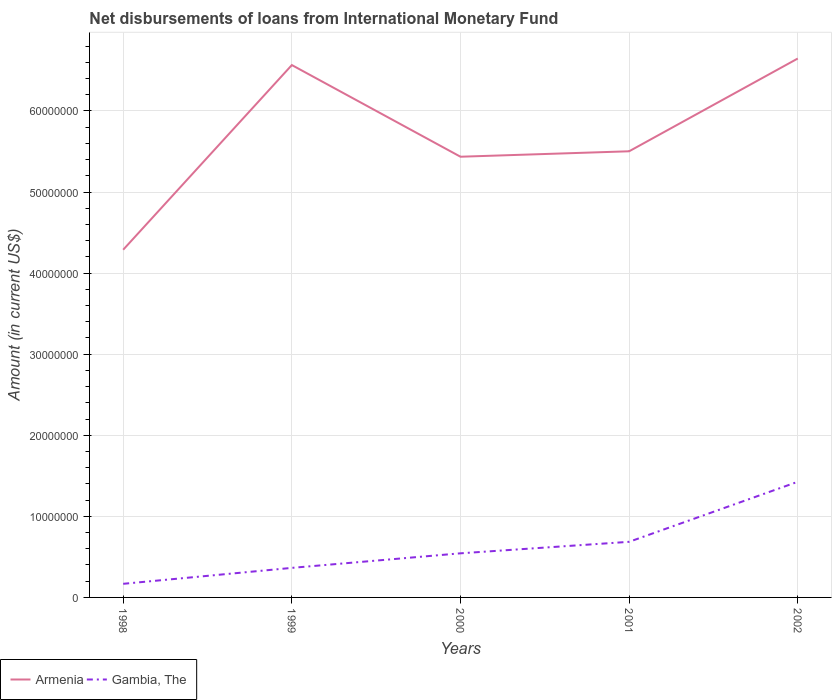Is the number of lines equal to the number of legend labels?
Make the answer very short. Yes. Across all years, what is the maximum amount of loans disbursed in Armenia?
Provide a short and direct response. 4.29e+07. In which year was the amount of loans disbursed in Gambia, The maximum?
Keep it short and to the point. 1998. What is the total amount of loans disbursed in Armenia in the graph?
Your answer should be compact. -1.14e+07. What is the difference between the highest and the second highest amount of loans disbursed in Gambia, The?
Ensure brevity in your answer.  1.26e+07. What is the difference between the highest and the lowest amount of loans disbursed in Gambia, The?
Provide a short and direct response. 2. How many lines are there?
Offer a terse response. 2. How many years are there in the graph?
Provide a short and direct response. 5. Does the graph contain grids?
Give a very brief answer. Yes. How are the legend labels stacked?
Make the answer very short. Horizontal. What is the title of the graph?
Offer a terse response. Net disbursements of loans from International Monetary Fund. What is the label or title of the X-axis?
Provide a succinct answer. Years. What is the Amount (in current US$) of Armenia in 1998?
Keep it short and to the point. 4.29e+07. What is the Amount (in current US$) of Gambia, The in 1998?
Your response must be concise. 1.68e+06. What is the Amount (in current US$) of Armenia in 1999?
Keep it short and to the point. 6.57e+07. What is the Amount (in current US$) in Gambia, The in 1999?
Give a very brief answer. 3.64e+06. What is the Amount (in current US$) in Armenia in 2000?
Offer a very short reply. 5.44e+07. What is the Amount (in current US$) of Gambia, The in 2000?
Make the answer very short. 5.44e+06. What is the Amount (in current US$) in Armenia in 2001?
Provide a succinct answer. 5.50e+07. What is the Amount (in current US$) in Gambia, The in 2001?
Ensure brevity in your answer.  6.86e+06. What is the Amount (in current US$) in Armenia in 2002?
Your answer should be compact. 6.65e+07. What is the Amount (in current US$) of Gambia, The in 2002?
Make the answer very short. 1.43e+07. Across all years, what is the maximum Amount (in current US$) in Armenia?
Provide a succinct answer. 6.65e+07. Across all years, what is the maximum Amount (in current US$) of Gambia, The?
Make the answer very short. 1.43e+07. Across all years, what is the minimum Amount (in current US$) of Armenia?
Your answer should be very brief. 4.29e+07. Across all years, what is the minimum Amount (in current US$) in Gambia, The?
Provide a short and direct response. 1.68e+06. What is the total Amount (in current US$) of Armenia in the graph?
Keep it short and to the point. 2.84e+08. What is the total Amount (in current US$) in Gambia, The in the graph?
Provide a succinct answer. 3.19e+07. What is the difference between the Amount (in current US$) of Armenia in 1998 and that in 1999?
Keep it short and to the point. -2.28e+07. What is the difference between the Amount (in current US$) in Gambia, The in 1998 and that in 1999?
Keep it short and to the point. -1.97e+06. What is the difference between the Amount (in current US$) in Armenia in 1998 and that in 2000?
Your answer should be compact. -1.15e+07. What is the difference between the Amount (in current US$) in Gambia, The in 1998 and that in 2000?
Ensure brevity in your answer.  -3.76e+06. What is the difference between the Amount (in current US$) of Armenia in 1998 and that in 2001?
Provide a succinct answer. -1.21e+07. What is the difference between the Amount (in current US$) in Gambia, The in 1998 and that in 2001?
Provide a succinct answer. -5.18e+06. What is the difference between the Amount (in current US$) of Armenia in 1998 and that in 2002?
Your answer should be very brief. -2.36e+07. What is the difference between the Amount (in current US$) in Gambia, The in 1998 and that in 2002?
Provide a succinct answer. -1.26e+07. What is the difference between the Amount (in current US$) of Armenia in 1999 and that in 2000?
Keep it short and to the point. 1.13e+07. What is the difference between the Amount (in current US$) of Gambia, The in 1999 and that in 2000?
Offer a very short reply. -1.80e+06. What is the difference between the Amount (in current US$) of Armenia in 1999 and that in 2001?
Ensure brevity in your answer.  1.06e+07. What is the difference between the Amount (in current US$) in Gambia, The in 1999 and that in 2001?
Provide a succinct answer. -3.21e+06. What is the difference between the Amount (in current US$) of Armenia in 1999 and that in 2002?
Ensure brevity in your answer.  -8.07e+05. What is the difference between the Amount (in current US$) in Gambia, The in 1999 and that in 2002?
Offer a very short reply. -1.06e+07. What is the difference between the Amount (in current US$) of Armenia in 2000 and that in 2001?
Offer a terse response. -6.72e+05. What is the difference between the Amount (in current US$) of Gambia, The in 2000 and that in 2001?
Your answer should be very brief. -1.42e+06. What is the difference between the Amount (in current US$) of Armenia in 2000 and that in 2002?
Offer a very short reply. -1.21e+07. What is the difference between the Amount (in current US$) in Gambia, The in 2000 and that in 2002?
Offer a terse response. -8.82e+06. What is the difference between the Amount (in current US$) of Armenia in 2001 and that in 2002?
Give a very brief answer. -1.14e+07. What is the difference between the Amount (in current US$) in Gambia, The in 2001 and that in 2002?
Give a very brief answer. -7.40e+06. What is the difference between the Amount (in current US$) of Armenia in 1998 and the Amount (in current US$) of Gambia, The in 1999?
Provide a short and direct response. 3.92e+07. What is the difference between the Amount (in current US$) of Armenia in 1998 and the Amount (in current US$) of Gambia, The in 2000?
Provide a succinct answer. 3.74e+07. What is the difference between the Amount (in current US$) in Armenia in 1998 and the Amount (in current US$) in Gambia, The in 2001?
Offer a very short reply. 3.60e+07. What is the difference between the Amount (in current US$) in Armenia in 1998 and the Amount (in current US$) in Gambia, The in 2002?
Offer a terse response. 2.86e+07. What is the difference between the Amount (in current US$) of Armenia in 1999 and the Amount (in current US$) of Gambia, The in 2000?
Give a very brief answer. 6.02e+07. What is the difference between the Amount (in current US$) in Armenia in 1999 and the Amount (in current US$) in Gambia, The in 2001?
Offer a very short reply. 5.88e+07. What is the difference between the Amount (in current US$) in Armenia in 1999 and the Amount (in current US$) in Gambia, The in 2002?
Provide a succinct answer. 5.14e+07. What is the difference between the Amount (in current US$) of Armenia in 2000 and the Amount (in current US$) of Gambia, The in 2001?
Keep it short and to the point. 4.75e+07. What is the difference between the Amount (in current US$) of Armenia in 2000 and the Amount (in current US$) of Gambia, The in 2002?
Provide a succinct answer. 4.01e+07. What is the difference between the Amount (in current US$) of Armenia in 2001 and the Amount (in current US$) of Gambia, The in 2002?
Provide a short and direct response. 4.08e+07. What is the average Amount (in current US$) in Armenia per year?
Give a very brief answer. 5.69e+07. What is the average Amount (in current US$) in Gambia, The per year?
Your response must be concise. 6.38e+06. In the year 1998, what is the difference between the Amount (in current US$) in Armenia and Amount (in current US$) in Gambia, The?
Ensure brevity in your answer.  4.12e+07. In the year 1999, what is the difference between the Amount (in current US$) of Armenia and Amount (in current US$) of Gambia, The?
Give a very brief answer. 6.20e+07. In the year 2000, what is the difference between the Amount (in current US$) in Armenia and Amount (in current US$) in Gambia, The?
Offer a terse response. 4.89e+07. In the year 2001, what is the difference between the Amount (in current US$) in Armenia and Amount (in current US$) in Gambia, The?
Provide a short and direct response. 4.82e+07. In the year 2002, what is the difference between the Amount (in current US$) in Armenia and Amount (in current US$) in Gambia, The?
Give a very brief answer. 5.22e+07. What is the ratio of the Amount (in current US$) in Armenia in 1998 to that in 1999?
Make the answer very short. 0.65. What is the ratio of the Amount (in current US$) in Gambia, The in 1998 to that in 1999?
Give a very brief answer. 0.46. What is the ratio of the Amount (in current US$) in Armenia in 1998 to that in 2000?
Keep it short and to the point. 0.79. What is the ratio of the Amount (in current US$) of Gambia, The in 1998 to that in 2000?
Ensure brevity in your answer.  0.31. What is the ratio of the Amount (in current US$) in Armenia in 1998 to that in 2001?
Give a very brief answer. 0.78. What is the ratio of the Amount (in current US$) in Gambia, The in 1998 to that in 2001?
Provide a short and direct response. 0.24. What is the ratio of the Amount (in current US$) of Armenia in 1998 to that in 2002?
Ensure brevity in your answer.  0.65. What is the ratio of the Amount (in current US$) in Gambia, The in 1998 to that in 2002?
Your answer should be compact. 0.12. What is the ratio of the Amount (in current US$) in Armenia in 1999 to that in 2000?
Give a very brief answer. 1.21. What is the ratio of the Amount (in current US$) in Gambia, The in 1999 to that in 2000?
Ensure brevity in your answer.  0.67. What is the ratio of the Amount (in current US$) of Armenia in 1999 to that in 2001?
Make the answer very short. 1.19. What is the ratio of the Amount (in current US$) of Gambia, The in 1999 to that in 2001?
Your answer should be compact. 0.53. What is the ratio of the Amount (in current US$) in Armenia in 1999 to that in 2002?
Make the answer very short. 0.99. What is the ratio of the Amount (in current US$) in Gambia, The in 1999 to that in 2002?
Give a very brief answer. 0.26. What is the ratio of the Amount (in current US$) of Gambia, The in 2000 to that in 2001?
Your answer should be compact. 0.79. What is the ratio of the Amount (in current US$) in Armenia in 2000 to that in 2002?
Provide a short and direct response. 0.82. What is the ratio of the Amount (in current US$) of Gambia, The in 2000 to that in 2002?
Give a very brief answer. 0.38. What is the ratio of the Amount (in current US$) in Armenia in 2001 to that in 2002?
Your response must be concise. 0.83. What is the ratio of the Amount (in current US$) of Gambia, The in 2001 to that in 2002?
Your response must be concise. 0.48. What is the difference between the highest and the second highest Amount (in current US$) of Armenia?
Offer a very short reply. 8.07e+05. What is the difference between the highest and the second highest Amount (in current US$) of Gambia, The?
Ensure brevity in your answer.  7.40e+06. What is the difference between the highest and the lowest Amount (in current US$) in Armenia?
Offer a very short reply. 2.36e+07. What is the difference between the highest and the lowest Amount (in current US$) in Gambia, The?
Your answer should be very brief. 1.26e+07. 